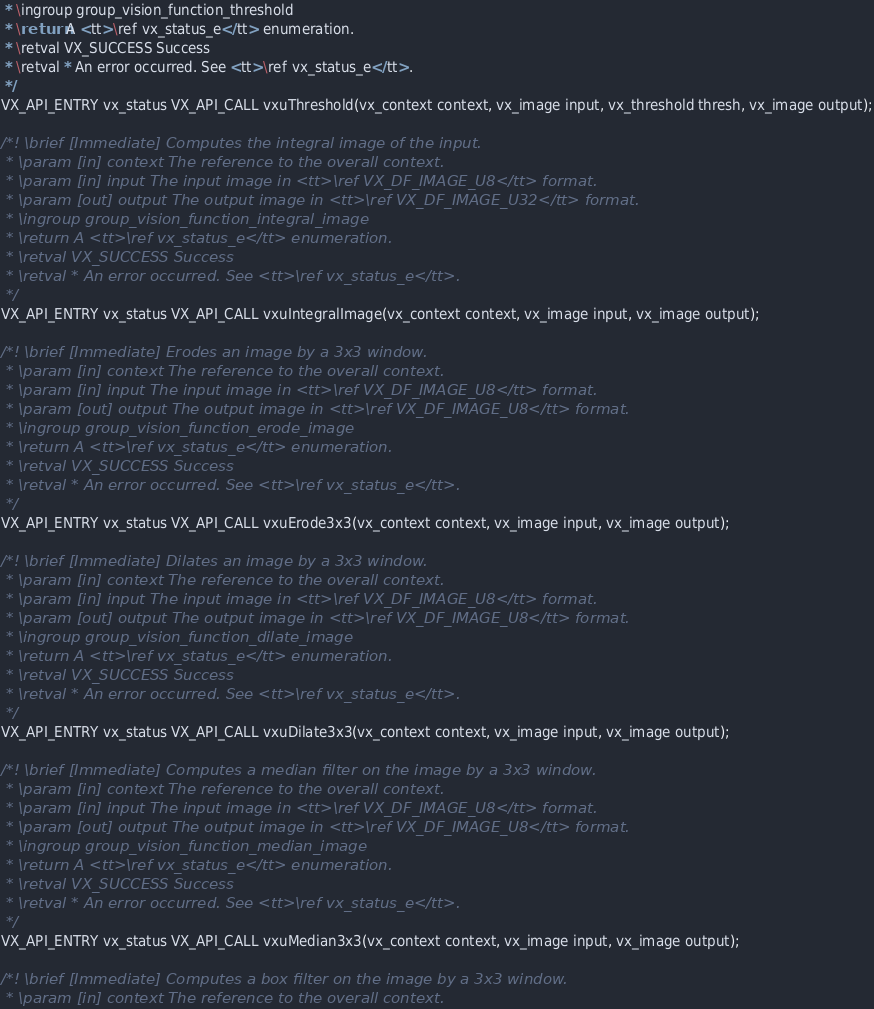<code> <loc_0><loc_0><loc_500><loc_500><_C_> * \ingroup group_vision_function_threshold
 * \return A <tt>\ref vx_status_e</tt> enumeration.
 * \retval VX_SUCCESS Success
 * \retval * An error occurred. See <tt>\ref vx_status_e</tt>.
 */
VX_API_ENTRY vx_status VX_API_CALL vxuThreshold(vx_context context, vx_image input, vx_threshold thresh, vx_image output);

/*! \brief [Immediate] Computes the integral image of the input.
 * \param [in] context The reference to the overall context.
 * \param [in] input The input image in <tt>\ref VX_DF_IMAGE_U8</tt> format.
 * \param [out] output The output image in <tt>\ref VX_DF_IMAGE_U32</tt> format.
 * \ingroup group_vision_function_integral_image
 * \return A <tt>\ref vx_status_e</tt> enumeration.
 * \retval VX_SUCCESS Success
 * \retval * An error occurred. See <tt>\ref vx_status_e</tt>.
 */
VX_API_ENTRY vx_status VX_API_CALL vxuIntegralImage(vx_context context, vx_image input, vx_image output);

/*! \brief [Immediate] Erodes an image by a 3x3 window.
 * \param [in] context The reference to the overall context.
 * \param [in] input The input image in <tt>\ref VX_DF_IMAGE_U8</tt> format.
 * \param [out] output The output image in <tt>\ref VX_DF_IMAGE_U8</tt> format.
 * \ingroup group_vision_function_erode_image
 * \return A <tt>\ref vx_status_e</tt> enumeration.
 * \retval VX_SUCCESS Success
 * \retval * An error occurred. See <tt>\ref vx_status_e</tt>.
 */
VX_API_ENTRY vx_status VX_API_CALL vxuErode3x3(vx_context context, vx_image input, vx_image output);

/*! \brief [Immediate] Dilates an image by a 3x3 window.
 * \param [in] context The reference to the overall context.
 * \param [in] input The input image in <tt>\ref VX_DF_IMAGE_U8</tt> format.
 * \param [out] output The output image in <tt>\ref VX_DF_IMAGE_U8</tt> format.
 * \ingroup group_vision_function_dilate_image
 * \return A <tt>\ref vx_status_e</tt> enumeration.
 * \retval VX_SUCCESS Success
 * \retval * An error occurred. See <tt>\ref vx_status_e</tt>.
 */
VX_API_ENTRY vx_status VX_API_CALL vxuDilate3x3(vx_context context, vx_image input, vx_image output);

/*! \brief [Immediate] Computes a median filter on the image by a 3x3 window.
 * \param [in] context The reference to the overall context.
 * \param [in] input The input image in <tt>\ref VX_DF_IMAGE_U8</tt> format.
 * \param [out] output The output image in <tt>\ref VX_DF_IMAGE_U8</tt> format.
 * \ingroup group_vision_function_median_image
 * \return A <tt>\ref vx_status_e</tt> enumeration.
 * \retval VX_SUCCESS Success
 * \retval * An error occurred. See <tt>\ref vx_status_e</tt>.
 */
VX_API_ENTRY vx_status VX_API_CALL vxuMedian3x3(vx_context context, vx_image input, vx_image output);

/*! \brief [Immediate] Computes a box filter on the image by a 3x3 window.
 * \param [in] context The reference to the overall context.</code> 